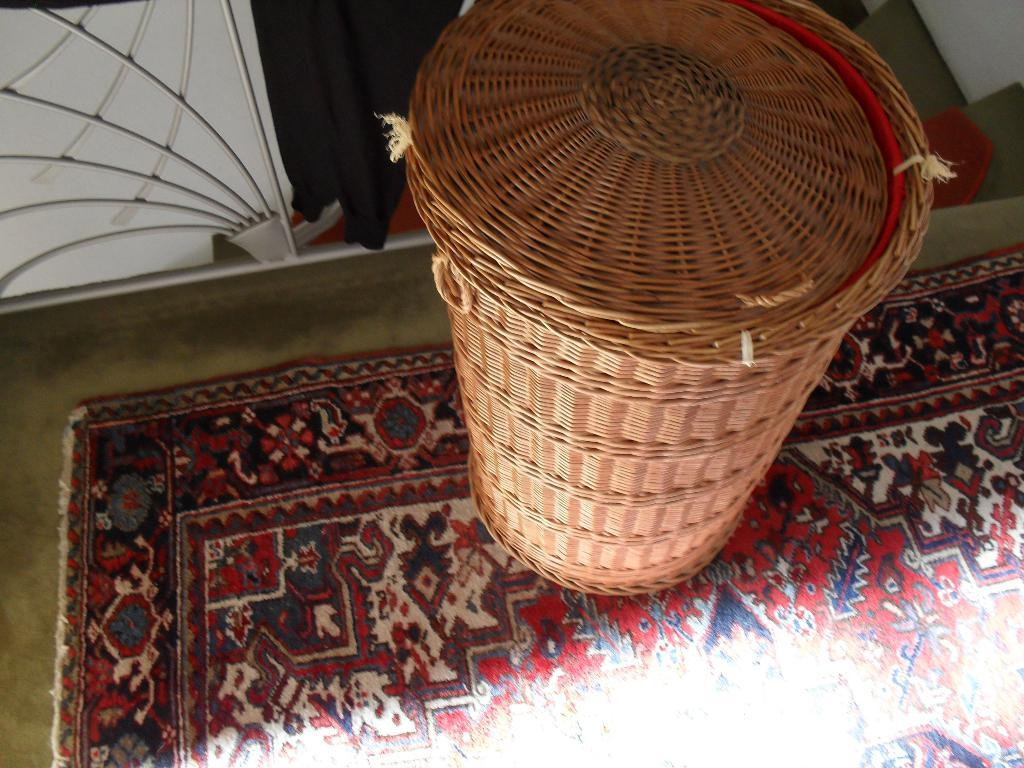What object is located on the floor in the image? There is a bin on the floor in the image. What type of surface is the bin placed on? The floor is covered with a carpet. What type of icicle can be seen hanging from the bin in the image? There is no icicle present in the image; it is a bin on the floor with a carpeted surface. 